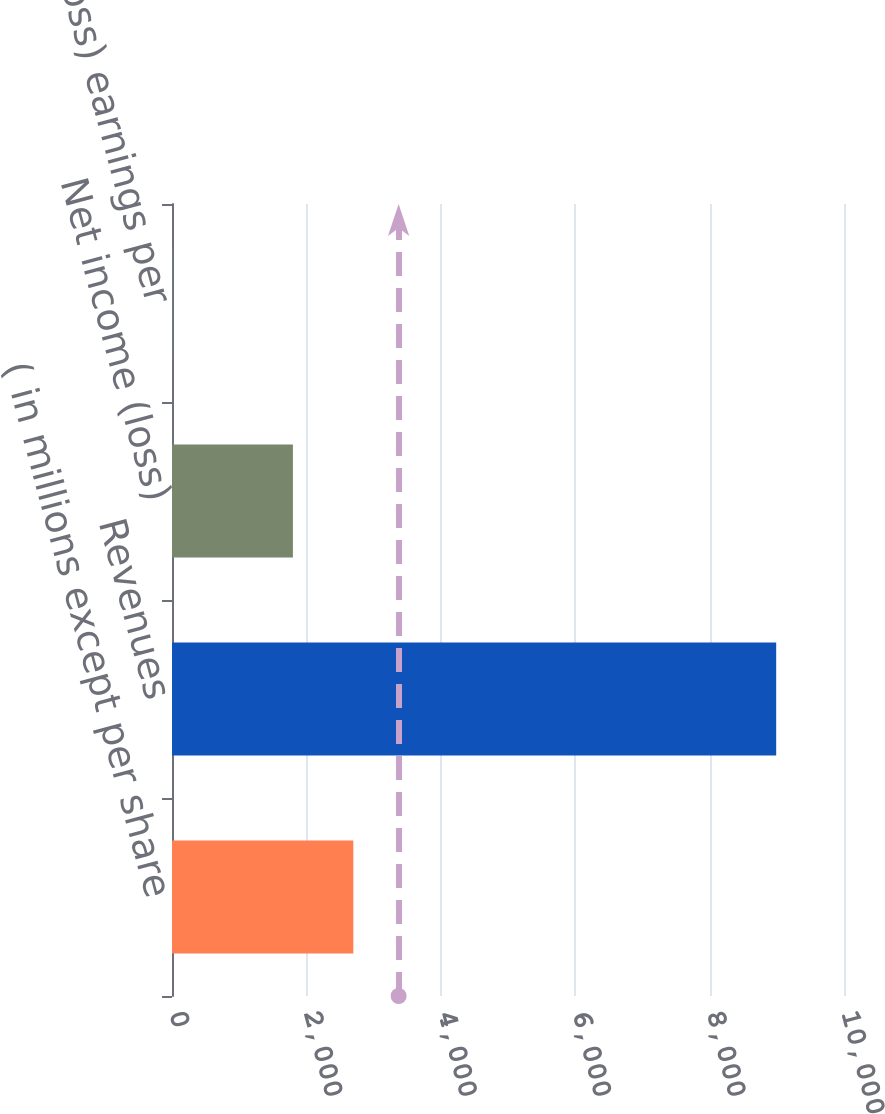<chart> <loc_0><loc_0><loc_500><loc_500><bar_chart><fcel>( in millions except per share<fcel>Revenues<fcel>Net income (loss)<fcel>Net income (loss) earnings per<nl><fcel>2698.24<fcel>8991<fcel>1799.28<fcel>1.36<nl></chart> 